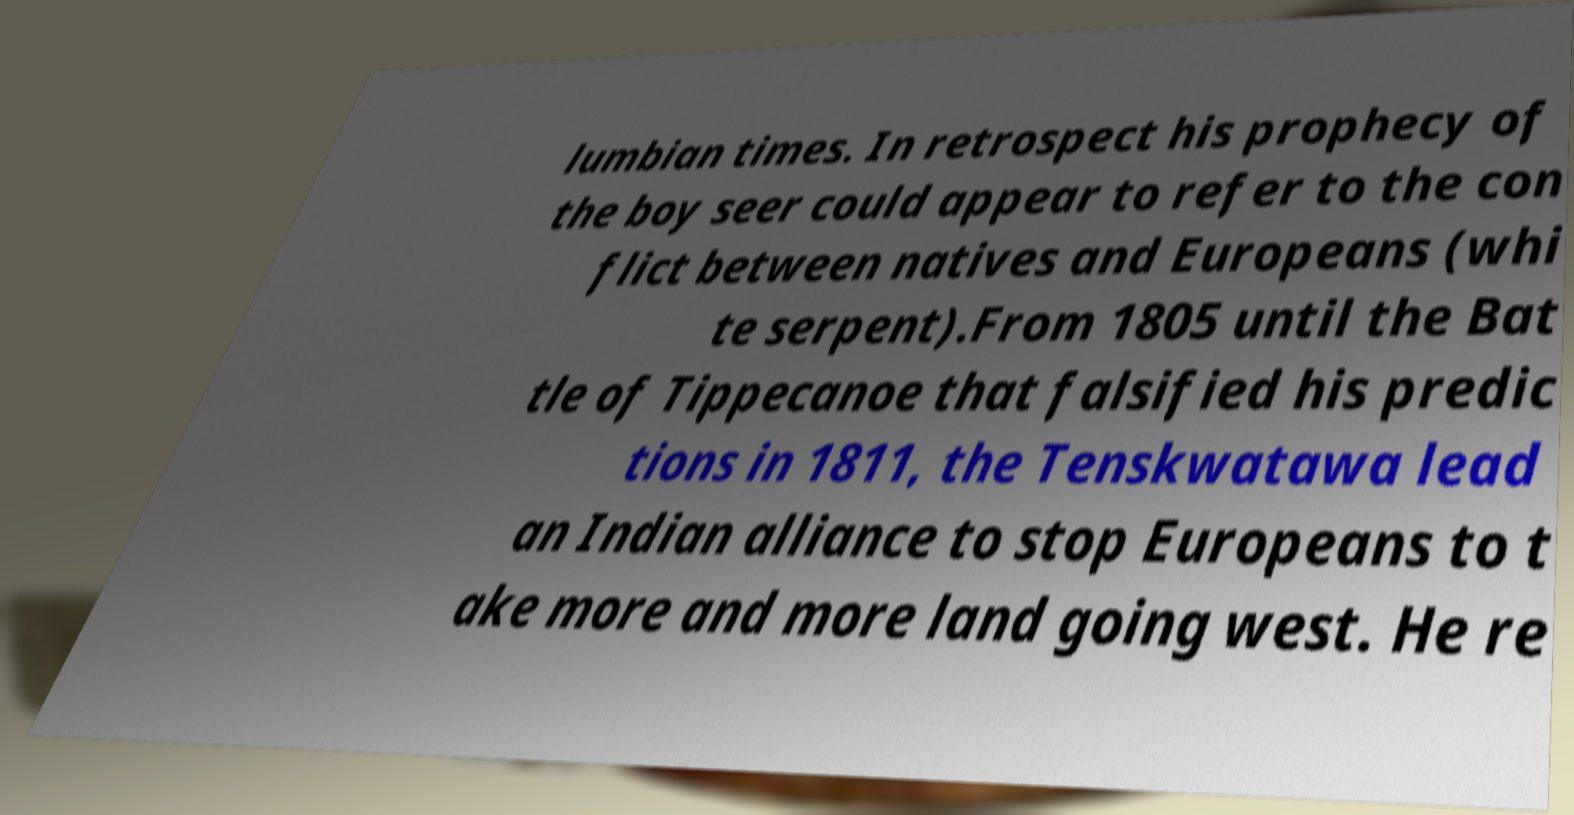Could you assist in decoding the text presented in this image and type it out clearly? lumbian times. In retrospect his prophecy of the boy seer could appear to refer to the con flict between natives and Europeans (whi te serpent).From 1805 until the Bat tle of Tippecanoe that falsified his predic tions in 1811, the Tenskwatawa lead an Indian alliance to stop Europeans to t ake more and more land going west. He re 